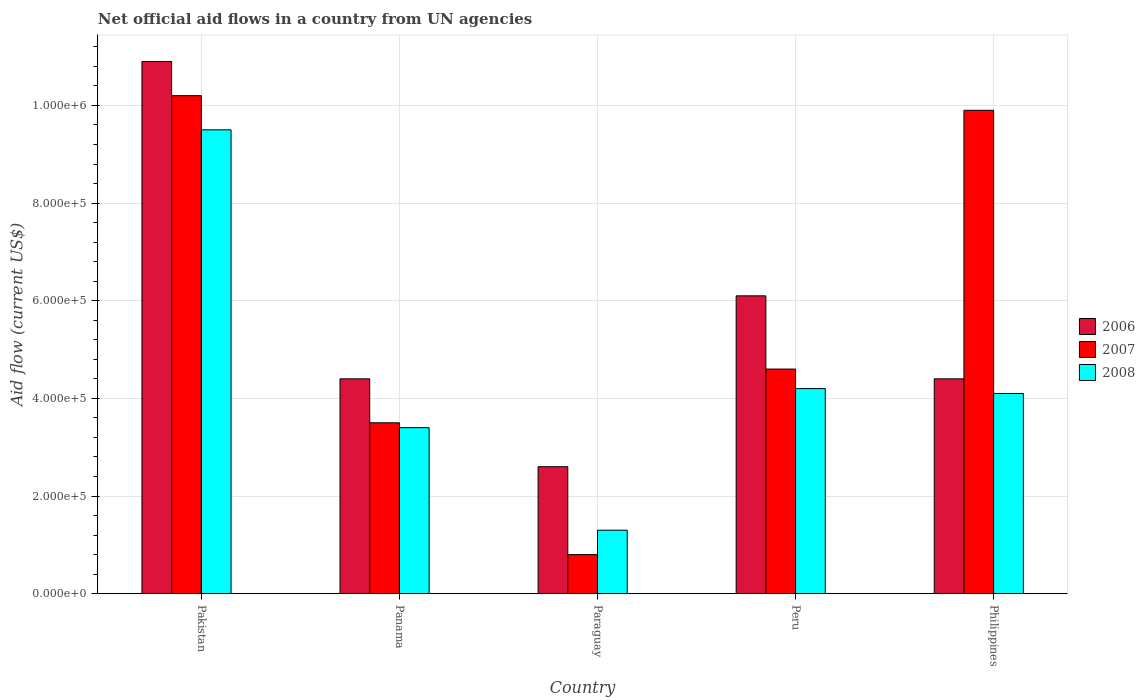How many different coloured bars are there?
Your response must be concise. 3. How many groups of bars are there?
Provide a succinct answer. 5. Are the number of bars per tick equal to the number of legend labels?
Ensure brevity in your answer.  Yes. How many bars are there on the 5th tick from the right?
Your answer should be compact. 3. What is the label of the 3rd group of bars from the left?
Make the answer very short. Paraguay. What is the net official aid flow in 2007 in Panama?
Keep it short and to the point. 3.50e+05. Across all countries, what is the maximum net official aid flow in 2006?
Offer a terse response. 1.09e+06. Across all countries, what is the minimum net official aid flow in 2008?
Your response must be concise. 1.30e+05. In which country was the net official aid flow in 2006 maximum?
Your response must be concise. Pakistan. In which country was the net official aid flow in 2008 minimum?
Keep it short and to the point. Paraguay. What is the total net official aid flow in 2007 in the graph?
Keep it short and to the point. 2.90e+06. What is the difference between the net official aid flow in 2006 in Panama and that in Philippines?
Keep it short and to the point. 0. What is the difference between the net official aid flow in 2006 in Peru and the net official aid flow in 2007 in Pakistan?
Make the answer very short. -4.10e+05. What is the average net official aid flow in 2007 per country?
Make the answer very short. 5.80e+05. What is the difference between the net official aid flow of/in 2007 and net official aid flow of/in 2008 in Paraguay?
Offer a very short reply. -5.00e+04. In how many countries, is the net official aid flow in 2006 greater than 760000 US$?
Ensure brevity in your answer.  1. What is the ratio of the net official aid flow in 2007 in Pakistan to that in Philippines?
Provide a short and direct response. 1.03. Is the net official aid flow in 2008 in Panama less than that in Paraguay?
Your answer should be very brief. No. What is the difference between the highest and the second highest net official aid flow in 2006?
Keep it short and to the point. 6.50e+05. What is the difference between the highest and the lowest net official aid flow in 2006?
Your answer should be very brief. 8.30e+05. Is the sum of the net official aid flow in 2008 in Paraguay and Peru greater than the maximum net official aid flow in 2007 across all countries?
Offer a very short reply. No. What does the 2nd bar from the right in Peru represents?
Provide a succinct answer. 2007. How many bars are there?
Offer a terse response. 15. Are all the bars in the graph horizontal?
Ensure brevity in your answer.  No. What is the difference between two consecutive major ticks on the Y-axis?
Ensure brevity in your answer.  2.00e+05. Are the values on the major ticks of Y-axis written in scientific E-notation?
Make the answer very short. Yes. Does the graph contain any zero values?
Ensure brevity in your answer.  No. Does the graph contain grids?
Provide a succinct answer. Yes. Where does the legend appear in the graph?
Your response must be concise. Center right. What is the title of the graph?
Provide a short and direct response. Net official aid flows in a country from UN agencies. Does "2009" appear as one of the legend labels in the graph?
Your answer should be very brief. No. What is the Aid flow (current US$) of 2006 in Pakistan?
Your response must be concise. 1.09e+06. What is the Aid flow (current US$) in 2007 in Pakistan?
Your answer should be very brief. 1.02e+06. What is the Aid flow (current US$) in 2008 in Pakistan?
Ensure brevity in your answer.  9.50e+05. What is the Aid flow (current US$) in 2006 in Panama?
Give a very brief answer. 4.40e+05. What is the Aid flow (current US$) in 2008 in Panama?
Make the answer very short. 3.40e+05. What is the Aid flow (current US$) of 2006 in Paraguay?
Your answer should be very brief. 2.60e+05. What is the Aid flow (current US$) of 2007 in Paraguay?
Your response must be concise. 8.00e+04. What is the Aid flow (current US$) in 2008 in Paraguay?
Your answer should be very brief. 1.30e+05. What is the Aid flow (current US$) in 2006 in Peru?
Your answer should be compact. 6.10e+05. What is the Aid flow (current US$) in 2008 in Peru?
Offer a terse response. 4.20e+05. What is the Aid flow (current US$) in 2007 in Philippines?
Your answer should be very brief. 9.90e+05. Across all countries, what is the maximum Aid flow (current US$) of 2006?
Your answer should be very brief. 1.09e+06. Across all countries, what is the maximum Aid flow (current US$) of 2007?
Your answer should be compact. 1.02e+06. Across all countries, what is the maximum Aid flow (current US$) in 2008?
Your response must be concise. 9.50e+05. Across all countries, what is the minimum Aid flow (current US$) of 2008?
Keep it short and to the point. 1.30e+05. What is the total Aid flow (current US$) of 2006 in the graph?
Ensure brevity in your answer.  2.84e+06. What is the total Aid flow (current US$) in 2007 in the graph?
Your answer should be compact. 2.90e+06. What is the total Aid flow (current US$) in 2008 in the graph?
Keep it short and to the point. 2.25e+06. What is the difference between the Aid flow (current US$) in 2006 in Pakistan and that in Panama?
Give a very brief answer. 6.50e+05. What is the difference between the Aid flow (current US$) in 2007 in Pakistan and that in Panama?
Your response must be concise. 6.70e+05. What is the difference between the Aid flow (current US$) of 2006 in Pakistan and that in Paraguay?
Offer a terse response. 8.30e+05. What is the difference between the Aid flow (current US$) of 2007 in Pakistan and that in Paraguay?
Offer a terse response. 9.40e+05. What is the difference between the Aid flow (current US$) in 2008 in Pakistan and that in Paraguay?
Make the answer very short. 8.20e+05. What is the difference between the Aid flow (current US$) in 2007 in Pakistan and that in Peru?
Keep it short and to the point. 5.60e+05. What is the difference between the Aid flow (current US$) of 2008 in Pakistan and that in Peru?
Offer a very short reply. 5.30e+05. What is the difference between the Aid flow (current US$) of 2006 in Pakistan and that in Philippines?
Offer a terse response. 6.50e+05. What is the difference between the Aid flow (current US$) of 2008 in Pakistan and that in Philippines?
Provide a succinct answer. 5.40e+05. What is the difference between the Aid flow (current US$) of 2007 in Panama and that in Paraguay?
Give a very brief answer. 2.70e+05. What is the difference between the Aid flow (current US$) in 2008 in Panama and that in Peru?
Your answer should be very brief. -8.00e+04. What is the difference between the Aid flow (current US$) of 2007 in Panama and that in Philippines?
Give a very brief answer. -6.40e+05. What is the difference between the Aid flow (current US$) of 2006 in Paraguay and that in Peru?
Offer a terse response. -3.50e+05. What is the difference between the Aid flow (current US$) of 2007 in Paraguay and that in Peru?
Provide a short and direct response. -3.80e+05. What is the difference between the Aid flow (current US$) of 2008 in Paraguay and that in Peru?
Offer a very short reply. -2.90e+05. What is the difference between the Aid flow (current US$) in 2006 in Paraguay and that in Philippines?
Your answer should be very brief. -1.80e+05. What is the difference between the Aid flow (current US$) in 2007 in Paraguay and that in Philippines?
Offer a very short reply. -9.10e+05. What is the difference between the Aid flow (current US$) of 2008 in Paraguay and that in Philippines?
Your answer should be compact. -2.80e+05. What is the difference between the Aid flow (current US$) in 2006 in Peru and that in Philippines?
Provide a succinct answer. 1.70e+05. What is the difference between the Aid flow (current US$) of 2007 in Peru and that in Philippines?
Your answer should be compact. -5.30e+05. What is the difference between the Aid flow (current US$) of 2008 in Peru and that in Philippines?
Your answer should be very brief. 10000. What is the difference between the Aid flow (current US$) of 2006 in Pakistan and the Aid flow (current US$) of 2007 in Panama?
Your response must be concise. 7.40e+05. What is the difference between the Aid flow (current US$) of 2006 in Pakistan and the Aid flow (current US$) of 2008 in Panama?
Your answer should be compact. 7.50e+05. What is the difference between the Aid flow (current US$) in 2007 in Pakistan and the Aid flow (current US$) in 2008 in Panama?
Give a very brief answer. 6.80e+05. What is the difference between the Aid flow (current US$) of 2006 in Pakistan and the Aid flow (current US$) of 2007 in Paraguay?
Offer a terse response. 1.01e+06. What is the difference between the Aid flow (current US$) in 2006 in Pakistan and the Aid flow (current US$) in 2008 in Paraguay?
Your response must be concise. 9.60e+05. What is the difference between the Aid flow (current US$) of 2007 in Pakistan and the Aid flow (current US$) of 2008 in Paraguay?
Your answer should be compact. 8.90e+05. What is the difference between the Aid flow (current US$) in 2006 in Pakistan and the Aid flow (current US$) in 2007 in Peru?
Provide a succinct answer. 6.30e+05. What is the difference between the Aid flow (current US$) of 2006 in Pakistan and the Aid flow (current US$) of 2008 in Peru?
Offer a very short reply. 6.70e+05. What is the difference between the Aid flow (current US$) in 2007 in Pakistan and the Aid flow (current US$) in 2008 in Peru?
Offer a very short reply. 6.00e+05. What is the difference between the Aid flow (current US$) of 2006 in Pakistan and the Aid flow (current US$) of 2007 in Philippines?
Your answer should be very brief. 1.00e+05. What is the difference between the Aid flow (current US$) of 2006 in Pakistan and the Aid flow (current US$) of 2008 in Philippines?
Your answer should be very brief. 6.80e+05. What is the difference between the Aid flow (current US$) in 2007 in Pakistan and the Aid flow (current US$) in 2008 in Philippines?
Your response must be concise. 6.10e+05. What is the difference between the Aid flow (current US$) in 2006 in Panama and the Aid flow (current US$) in 2007 in Peru?
Make the answer very short. -2.00e+04. What is the difference between the Aid flow (current US$) in 2006 in Panama and the Aid flow (current US$) in 2008 in Peru?
Your answer should be very brief. 2.00e+04. What is the difference between the Aid flow (current US$) of 2006 in Panama and the Aid flow (current US$) of 2007 in Philippines?
Give a very brief answer. -5.50e+05. What is the difference between the Aid flow (current US$) in 2006 in Paraguay and the Aid flow (current US$) in 2007 in Peru?
Offer a terse response. -2.00e+05. What is the difference between the Aid flow (current US$) of 2006 in Paraguay and the Aid flow (current US$) of 2008 in Peru?
Your response must be concise. -1.60e+05. What is the difference between the Aid flow (current US$) in 2007 in Paraguay and the Aid flow (current US$) in 2008 in Peru?
Your answer should be very brief. -3.40e+05. What is the difference between the Aid flow (current US$) in 2006 in Paraguay and the Aid flow (current US$) in 2007 in Philippines?
Provide a short and direct response. -7.30e+05. What is the difference between the Aid flow (current US$) in 2006 in Paraguay and the Aid flow (current US$) in 2008 in Philippines?
Ensure brevity in your answer.  -1.50e+05. What is the difference between the Aid flow (current US$) of 2007 in Paraguay and the Aid flow (current US$) of 2008 in Philippines?
Provide a short and direct response. -3.30e+05. What is the difference between the Aid flow (current US$) in 2006 in Peru and the Aid flow (current US$) in 2007 in Philippines?
Your response must be concise. -3.80e+05. What is the difference between the Aid flow (current US$) of 2006 in Peru and the Aid flow (current US$) of 2008 in Philippines?
Provide a succinct answer. 2.00e+05. What is the average Aid flow (current US$) in 2006 per country?
Offer a terse response. 5.68e+05. What is the average Aid flow (current US$) of 2007 per country?
Your answer should be compact. 5.80e+05. What is the difference between the Aid flow (current US$) of 2006 and Aid flow (current US$) of 2008 in Pakistan?
Your answer should be compact. 1.40e+05. What is the difference between the Aid flow (current US$) in 2007 and Aid flow (current US$) in 2008 in Pakistan?
Provide a short and direct response. 7.00e+04. What is the difference between the Aid flow (current US$) of 2006 and Aid flow (current US$) of 2007 in Panama?
Offer a very short reply. 9.00e+04. What is the difference between the Aid flow (current US$) of 2006 and Aid flow (current US$) of 2008 in Panama?
Provide a succinct answer. 1.00e+05. What is the difference between the Aid flow (current US$) of 2007 and Aid flow (current US$) of 2008 in Panama?
Provide a succinct answer. 10000. What is the difference between the Aid flow (current US$) in 2006 and Aid flow (current US$) in 2007 in Paraguay?
Provide a succinct answer. 1.80e+05. What is the difference between the Aid flow (current US$) in 2006 and Aid flow (current US$) in 2008 in Paraguay?
Your answer should be compact. 1.30e+05. What is the difference between the Aid flow (current US$) in 2007 and Aid flow (current US$) in 2008 in Paraguay?
Your response must be concise. -5.00e+04. What is the difference between the Aid flow (current US$) in 2006 and Aid flow (current US$) in 2007 in Philippines?
Your response must be concise. -5.50e+05. What is the difference between the Aid flow (current US$) of 2007 and Aid flow (current US$) of 2008 in Philippines?
Give a very brief answer. 5.80e+05. What is the ratio of the Aid flow (current US$) in 2006 in Pakistan to that in Panama?
Keep it short and to the point. 2.48. What is the ratio of the Aid flow (current US$) of 2007 in Pakistan to that in Panama?
Keep it short and to the point. 2.91. What is the ratio of the Aid flow (current US$) of 2008 in Pakistan to that in Panama?
Provide a short and direct response. 2.79. What is the ratio of the Aid flow (current US$) of 2006 in Pakistan to that in Paraguay?
Provide a short and direct response. 4.19. What is the ratio of the Aid flow (current US$) of 2007 in Pakistan to that in Paraguay?
Your answer should be very brief. 12.75. What is the ratio of the Aid flow (current US$) in 2008 in Pakistan to that in Paraguay?
Make the answer very short. 7.31. What is the ratio of the Aid flow (current US$) in 2006 in Pakistan to that in Peru?
Keep it short and to the point. 1.79. What is the ratio of the Aid flow (current US$) in 2007 in Pakistan to that in Peru?
Ensure brevity in your answer.  2.22. What is the ratio of the Aid flow (current US$) of 2008 in Pakistan to that in Peru?
Provide a short and direct response. 2.26. What is the ratio of the Aid flow (current US$) of 2006 in Pakistan to that in Philippines?
Ensure brevity in your answer.  2.48. What is the ratio of the Aid flow (current US$) of 2007 in Pakistan to that in Philippines?
Give a very brief answer. 1.03. What is the ratio of the Aid flow (current US$) in 2008 in Pakistan to that in Philippines?
Make the answer very short. 2.32. What is the ratio of the Aid flow (current US$) in 2006 in Panama to that in Paraguay?
Provide a succinct answer. 1.69. What is the ratio of the Aid flow (current US$) of 2007 in Panama to that in Paraguay?
Your response must be concise. 4.38. What is the ratio of the Aid flow (current US$) of 2008 in Panama to that in Paraguay?
Your answer should be compact. 2.62. What is the ratio of the Aid flow (current US$) in 2006 in Panama to that in Peru?
Ensure brevity in your answer.  0.72. What is the ratio of the Aid flow (current US$) of 2007 in Panama to that in Peru?
Your response must be concise. 0.76. What is the ratio of the Aid flow (current US$) in 2008 in Panama to that in Peru?
Provide a succinct answer. 0.81. What is the ratio of the Aid flow (current US$) in 2007 in Panama to that in Philippines?
Offer a very short reply. 0.35. What is the ratio of the Aid flow (current US$) in 2008 in Panama to that in Philippines?
Make the answer very short. 0.83. What is the ratio of the Aid flow (current US$) in 2006 in Paraguay to that in Peru?
Ensure brevity in your answer.  0.43. What is the ratio of the Aid flow (current US$) of 2007 in Paraguay to that in Peru?
Your answer should be very brief. 0.17. What is the ratio of the Aid flow (current US$) in 2008 in Paraguay to that in Peru?
Provide a succinct answer. 0.31. What is the ratio of the Aid flow (current US$) in 2006 in Paraguay to that in Philippines?
Provide a short and direct response. 0.59. What is the ratio of the Aid flow (current US$) of 2007 in Paraguay to that in Philippines?
Keep it short and to the point. 0.08. What is the ratio of the Aid flow (current US$) in 2008 in Paraguay to that in Philippines?
Provide a succinct answer. 0.32. What is the ratio of the Aid flow (current US$) in 2006 in Peru to that in Philippines?
Offer a very short reply. 1.39. What is the ratio of the Aid flow (current US$) of 2007 in Peru to that in Philippines?
Your response must be concise. 0.46. What is the ratio of the Aid flow (current US$) of 2008 in Peru to that in Philippines?
Your response must be concise. 1.02. What is the difference between the highest and the second highest Aid flow (current US$) of 2006?
Ensure brevity in your answer.  4.80e+05. What is the difference between the highest and the second highest Aid flow (current US$) in 2008?
Your answer should be compact. 5.30e+05. What is the difference between the highest and the lowest Aid flow (current US$) of 2006?
Make the answer very short. 8.30e+05. What is the difference between the highest and the lowest Aid flow (current US$) of 2007?
Give a very brief answer. 9.40e+05. What is the difference between the highest and the lowest Aid flow (current US$) in 2008?
Make the answer very short. 8.20e+05. 